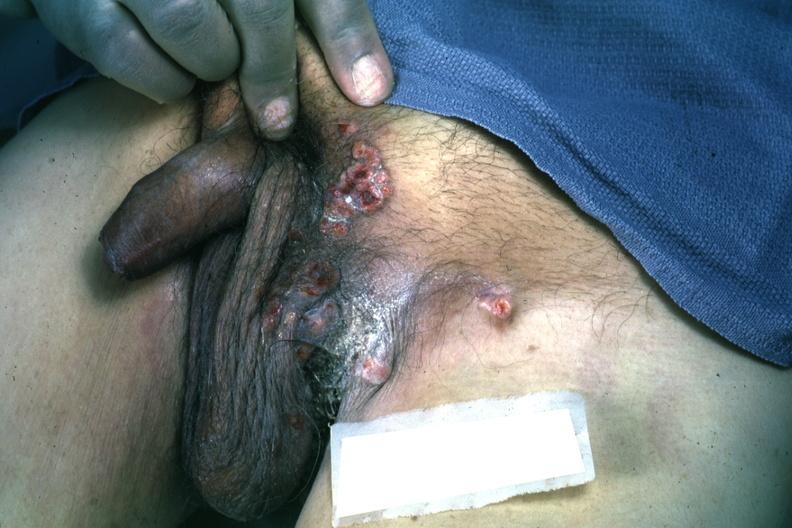s opened larynx present?
Answer the question using a single word or phrase. No 